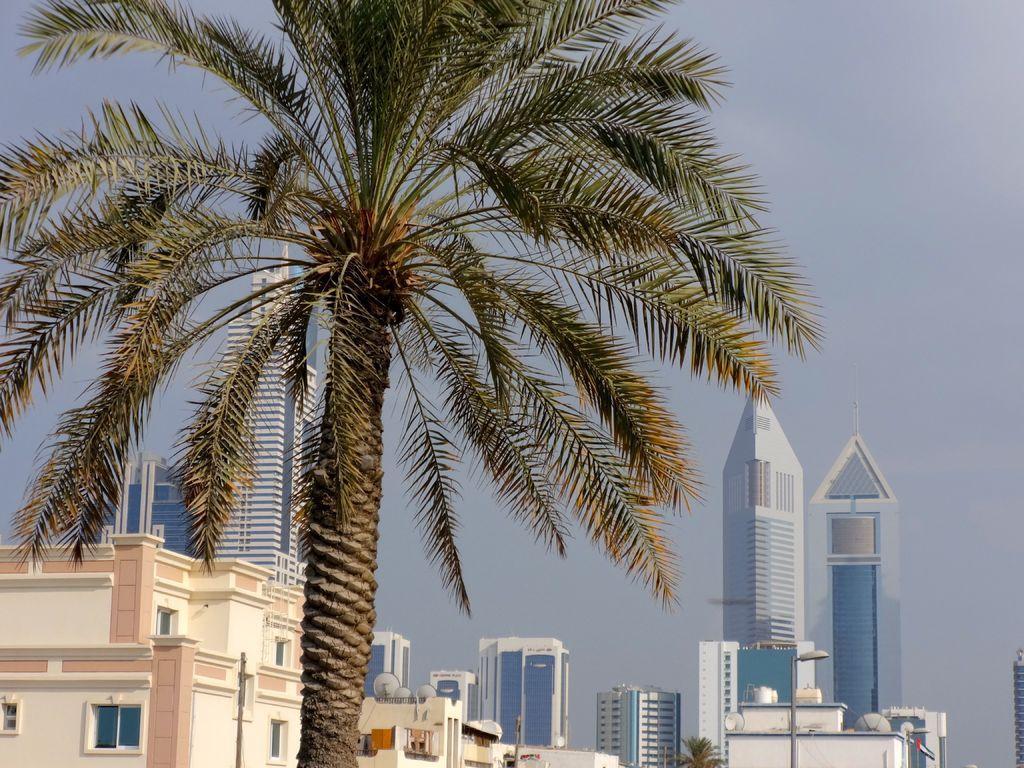Describe this image in one or two sentences. Here we can see a tree. In the background there are buildings,windows,dish antennas,light poles and sky. 